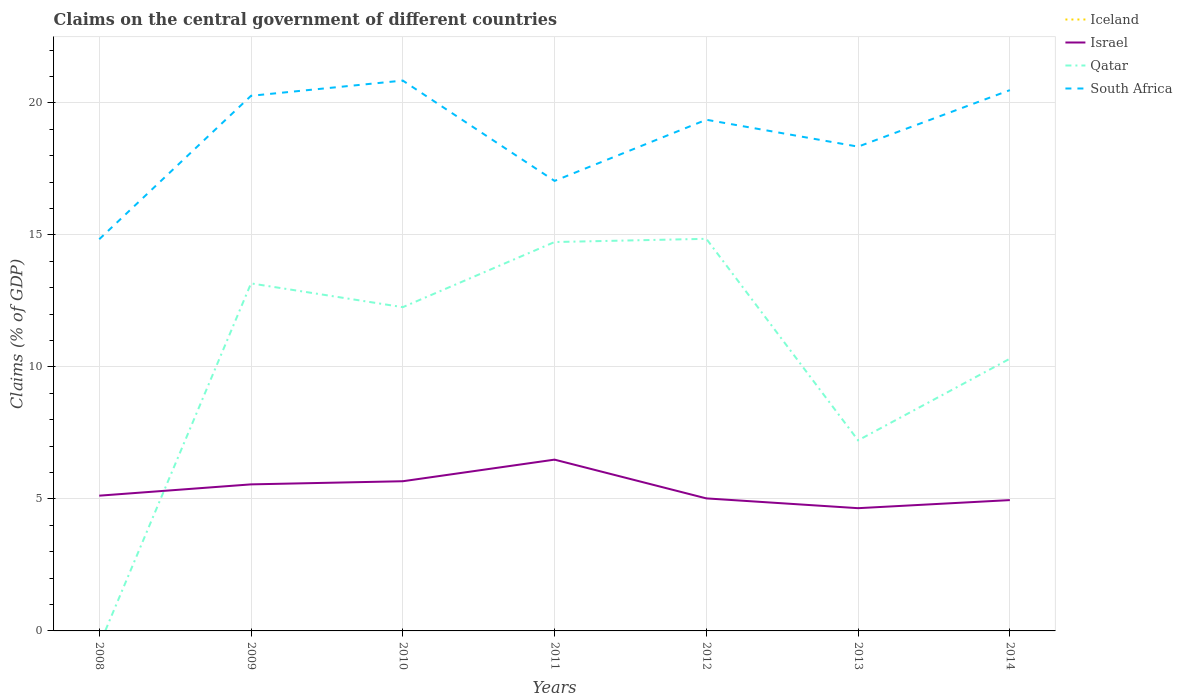Across all years, what is the maximum percentage of GDP claimed on the central government in Israel?
Offer a very short reply. 4.65. What is the total percentage of GDP claimed on the central government in South Africa in the graph?
Provide a short and direct response. 2.5. What is the difference between the highest and the second highest percentage of GDP claimed on the central government in Israel?
Ensure brevity in your answer.  1.84. What is the difference between the highest and the lowest percentage of GDP claimed on the central government in Iceland?
Your answer should be compact. 0. Is the percentage of GDP claimed on the central government in Qatar strictly greater than the percentage of GDP claimed on the central government in South Africa over the years?
Make the answer very short. Yes. How many years are there in the graph?
Your answer should be very brief. 7. Does the graph contain any zero values?
Ensure brevity in your answer.  Yes. Where does the legend appear in the graph?
Offer a very short reply. Top right. What is the title of the graph?
Provide a short and direct response. Claims on the central government of different countries. What is the label or title of the Y-axis?
Your answer should be compact. Claims (% of GDP). What is the Claims (% of GDP) of Iceland in 2008?
Offer a very short reply. 0. What is the Claims (% of GDP) of Israel in 2008?
Provide a succinct answer. 5.12. What is the Claims (% of GDP) in South Africa in 2008?
Make the answer very short. 14.84. What is the Claims (% of GDP) in Iceland in 2009?
Provide a short and direct response. 0. What is the Claims (% of GDP) of Israel in 2009?
Provide a succinct answer. 5.55. What is the Claims (% of GDP) in Qatar in 2009?
Make the answer very short. 13.16. What is the Claims (% of GDP) of South Africa in 2009?
Your answer should be very brief. 20.27. What is the Claims (% of GDP) of Israel in 2010?
Provide a succinct answer. 5.67. What is the Claims (% of GDP) of Qatar in 2010?
Provide a short and direct response. 12.26. What is the Claims (% of GDP) of South Africa in 2010?
Offer a terse response. 20.84. What is the Claims (% of GDP) of Israel in 2011?
Offer a terse response. 6.49. What is the Claims (% of GDP) in Qatar in 2011?
Give a very brief answer. 14.73. What is the Claims (% of GDP) of South Africa in 2011?
Keep it short and to the point. 17.04. What is the Claims (% of GDP) in Iceland in 2012?
Give a very brief answer. 0. What is the Claims (% of GDP) of Israel in 2012?
Your answer should be very brief. 5.02. What is the Claims (% of GDP) in Qatar in 2012?
Provide a short and direct response. 14.85. What is the Claims (% of GDP) in South Africa in 2012?
Offer a very short reply. 19.36. What is the Claims (% of GDP) in Israel in 2013?
Ensure brevity in your answer.  4.65. What is the Claims (% of GDP) in Qatar in 2013?
Keep it short and to the point. 7.22. What is the Claims (% of GDP) of South Africa in 2013?
Keep it short and to the point. 18.34. What is the Claims (% of GDP) of Israel in 2014?
Give a very brief answer. 4.96. What is the Claims (% of GDP) of Qatar in 2014?
Make the answer very short. 10.31. What is the Claims (% of GDP) in South Africa in 2014?
Offer a terse response. 20.48. Across all years, what is the maximum Claims (% of GDP) in Israel?
Offer a very short reply. 6.49. Across all years, what is the maximum Claims (% of GDP) in Qatar?
Offer a very short reply. 14.85. Across all years, what is the maximum Claims (% of GDP) in South Africa?
Give a very brief answer. 20.84. Across all years, what is the minimum Claims (% of GDP) of Israel?
Your answer should be very brief. 4.65. Across all years, what is the minimum Claims (% of GDP) of South Africa?
Provide a short and direct response. 14.84. What is the total Claims (% of GDP) of Israel in the graph?
Your response must be concise. 37.45. What is the total Claims (% of GDP) in Qatar in the graph?
Ensure brevity in your answer.  72.53. What is the total Claims (% of GDP) in South Africa in the graph?
Your answer should be very brief. 131.18. What is the difference between the Claims (% of GDP) of Israel in 2008 and that in 2009?
Keep it short and to the point. -0.43. What is the difference between the Claims (% of GDP) of South Africa in 2008 and that in 2009?
Provide a short and direct response. -5.43. What is the difference between the Claims (% of GDP) in Israel in 2008 and that in 2010?
Ensure brevity in your answer.  -0.55. What is the difference between the Claims (% of GDP) of South Africa in 2008 and that in 2010?
Keep it short and to the point. -6.01. What is the difference between the Claims (% of GDP) of Israel in 2008 and that in 2011?
Your answer should be very brief. -1.36. What is the difference between the Claims (% of GDP) in South Africa in 2008 and that in 2011?
Your answer should be compact. -2.21. What is the difference between the Claims (% of GDP) of Israel in 2008 and that in 2012?
Make the answer very short. 0.1. What is the difference between the Claims (% of GDP) in South Africa in 2008 and that in 2012?
Provide a short and direct response. -4.53. What is the difference between the Claims (% of GDP) of Israel in 2008 and that in 2013?
Ensure brevity in your answer.  0.47. What is the difference between the Claims (% of GDP) in South Africa in 2008 and that in 2013?
Offer a very short reply. -3.51. What is the difference between the Claims (% of GDP) in Israel in 2008 and that in 2014?
Your answer should be compact. 0.17. What is the difference between the Claims (% of GDP) of South Africa in 2008 and that in 2014?
Offer a terse response. -5.65. What is the difference between the Claims (% of GDP) in Israel in 2009 and that in 2010?
Keep it short and to the point. -0.12. What is the difference between the Claims (% of GDP) in Qatar in 2009 and that in 2010?
Your answer should be compact. 0.9. What is the difference between the Claims (% of GDP) in South Africa in 2009 and that in 2010?
Offer a terse response. -0.58. What is the difference between the Claims (% of GDP) of Israel in 2009 and that in 2011?
Give a very brief answer. -0.94. What is the difference between the Claims (% of GDP) in Qatar in 2009 and that in 2011?
Your answer should be very brief. -1.57. What is the difference between the Claims (% of GDP) of South Africa in 2009 and that in 2011?
Keep it short and to the point. 3.22. What is the difference between the Claims (% of GDP) of Israel in 2009 and that in 2012?
Make the answer very short. 0.53. What is the difference between the Claims (% of GDP) of Qatar in 2009 and that in 2012?
Your response must be concise. -1.69. What is the difference between the Claims (% of GDP) in South Africa in 2009 and that in 2012?
Offer a very short reply. 0.91. What is the difference between the Claims (% of GDP) in Israel in 2009 and that in 2013?
Your response must be concise. 0.9. What is the difference between the Claims (% of GDP) of Qatar in 2009 and that in 2013?
Keep it short and to the point. 5.94. What is the difference between the Claims (% of GDP) of South Africa in 2009 and that in 2013?
Make the answer very short. 1.93. What is the difference between the Claims (% of GDP) in Israel in 2009 and that in 2014?
Make the answer very short. 0.6. What is the difference between the Claims (% of GDP) in Qatar in 2009 and that in 2014?
Give a very brief answer. 2.85. What is the difference between the Claims (% of GDP) of South Africa in 2009 and that in 2014?
Your answer should be compact. -0.21. What is the difference between the Claims (% of GDP) in Israel in 2010 and that in 2011?
Offer a terse response. -0.82. What is the difference between the Claims (% of GDP) of Qatar in 2010 and that in 2011?
Make the answer very short. -2.47. What is the difference between the Claims (% of GDP) of Israel in 2010 and that in 2012?
Give a very brief answer. 0.65. What is the difference between the Claims (% of GDP) in Qatar in 2010 and that in 2012?
Ensure brevity in your answer.  -2.59. What is the difference between the Claims (% of GDP) in South Africa in 2010 and that in 2012?
Make the answer very short. 1.48. What is the difference between the Claims (% of GDP) in Israel in 2010 and that in 2013?
Give a very brief answer. 1.02. What is the difference between the Claims (% of GDP) of Qatar in 2010 and that in 2013?
Make the answer very short. 5.04. What is the difference between the Claims (% of GDP) of South Africa in 2010 and that in 2013?
Make the answer very short. 2.5. What is the difference between the Claims (% of GDP) of Israel in 2010 and that in 2014?
Make the answer very short. 0.71. What is the difference between the Claims (% of GDP) of Qatar in 2010 and that in 2014?
Make the answer very short. 1.95. What is the difference between the Claims (% of GDP) in South Africa in 2010 and that in 2014?
Provide a succinct answer. 0.36. What is the difference between the Claims (% of GDP) of Israel in 2011 and that in 2012?
Make the answer very short. 1.47. What is the difference between the Claims (% of GDP) of Qatar in 2011 and that in 2012?
Provide a short and direct response. -0.12. What is the difference between the Claims (% of GDP) of South Africa in 2011 and that in 2012?
Your answer should be very brief. -2.32. What is the difference between the Claims (% of GDP) in Israel in 2011 and that in 2013?
Make the answer very short. 1.84. What is the difference between the Claims (% of GDP) in Qatar in 2011 and that in 2013?
Provide a short and direct response. 7.51. What is the difference between the Claims (% of GDP) in South Africa in 2011 and that in 2013?
Provide a short and direct response. -1.3. What is the difference between the Claims (% of GDP) in Israel in 2011 and that in 2014?
Offer a terse response. 1.53. What is the difference between the Claims (% of GDP) in Qatar in 2011 and that in 2014?
Make the answer very short. 4.42. What is the difference between the Claims (% of GDP) of South Africa in 2011 and that in 2014?
Keep it short and to the point. -3.44. What is the difference between the Claims (% of GDP) in Israel in 2012 and that in 2013?
Ensure brevity in your answer.  0.37. What is the difference between the Claims (% of GDP) in Qatar in 2012 and that in 2013?
Your response must be concise. 7.63. What is the difference between the Claims (% of GDP) in South Africa in 2012 and that in 2013?
Keep it short and to the point. 1.02. What is the difference between the Claims (% of GDP) in Israel in 2012 and that in 2014?
Provide a short and direct response. 0.06. What is the difference between the Claims (% of GDP) in Qatar in 2012 and that in 2014?
Give a very brief answer. 4.54. What is the difference between the Claims (% of GDP) in South Africa in 2012 and that in 2014?
Make the answer very short. -1.12. What is the difference between the Claims (% of GDP) of Israel in 2013 and that in 2014?
Your answer should be compact. -0.31. What is the difference between the Claims (% of GDP) of Qatar in 2013 and that in 2014?
Offer a very short reply. -3.09. What is the difference between the Claims (% of GDP) of South Africa in 2013 and that in 2014?
Your answer should be very brief. -2.14. What is the difference between the Claims (% of GDP) in Israel in 2008 and the Claims (% of GDP) in Qatar in 2009?
Offer a terse response. -8.04. What is the difference between the Claims (% of GDP) in Israel in 2008 and the Claims (% of GDP) in South Africa in 2009?
Keep it short and to the point. -15.14. What is the difference between the Claims (% of GDP) in Israel in 2008 and the Claims (% of GDP) in Qatar in 2010?
Make the answer very short. -7.14. What is the difference between the Claims (% of GDP) of Israel in 2008 and the Claims (% of GDP) of South Africa in 2010?
Keep it short and to the point. -15.72. What is the difference between the Claims (% of GDP) of Israel in 2008 and the Claims (% of GDP) of Qatar in 2011?
Offer a very short reply. -9.61. What is the difference between the Claims (% of GDP) of Israel in 2008 and the Claims (% of GDP) of South Africa in 2011?
Offer a terse response. -11.92. What is the difference between the Claims (% of GDP) in Israel in 2008 and the Claims (% of GDP) in Qatar in 2012?
Provide a succinct answer. -9.73. What is the difference between the Claims (% of GDP) in Israel in 2008 and the Claims (% of GDP) in South Africa in 2012?
Make the answer very short. -14.24. What is the difference between the Claims (% of GDP) in Israel in 2008 and the Claims (% of GDP) in Qatar in 2013?
Provide a short and direct response. -2.1. What is the difference between the Claims (% of GDP) in Israel in 2008 and the Claims (% of GDP) in South Africa in 2013?
Offer a terse response. -13.22. What is the difference between the Claims (% of GDP) of Israel in 2008 and the Claims (% of GDP) of Qatar in 2014?
Your response must be concise. -5.19. What is the difference between the Claims (% of GDP) of Israel in 2008 and the Claims (% of GDP) of South Africa in 2014?
Ensure brevity in your answer.  -15.36. What is the difference between the Claims (% of GDP) of Israel in 2009 and the Claims (% of GDP) of Qatar in 2010?
Your answer should be compact. -6.71. What is the difference between the Claims (% of GDP) in Israel in 2009 and the Claims (% of GDP) in South Africa in 2010?
Give a very brief answer. -15.29. What is the difference between the Claims (% of GDP) in Qatar in 2009 and the Claims (% of GDP) in South Africa in 2010?
Give a very brief answer. -7.68. What is the difference between the Claims (% of GDP) of Israel in 2009 and the Claims (% of GDP) of Qatar in 2011?
Give a very brief answer. -9.18. What is the difference between the Claims (% of GDP) of Israel in 2009 and the Claims (% of GDP) of South Africa in 2011?
Your response must be concise. -11.49. What is the difference between the Claims (% of GDP) in Qatar in 2009 and the Claims (% of GDP) in South Africa in 2011?
Provide a succinct answer. -3.88. What is the difference between the Claims (% of GDP) in Israel in 2009 and the Claims (% of GDP) in South Africa in 2012?
Make the answer very short. -13.81. What is the difference between the Claims (% of GDP) in Qatar in 2009 and the Claims (% of GDP) in South Africa in 2012?
Your answer should be compact. -6.2. What is the difference between the Claims (% of GDP) in Israel in 2009 and the Claims (% of GDP) in Qatar in 2013?
Make the answer very short. -1.67. What is the difference between the Claims (% of GDP) in Israel in 2009 and the Claims (% of GDP) in South Africa in 2013?
Your answer should be very brief. -12.79. What is the difference between the Claims (% of GDP) of Qatar in 2009 and the Claims (% of GDP) of South Africa in 2013?
Your answer should be very brief. -5.18. What is the difference between the Claims (% of GDP) of Israel in 2009 and the Claims (% of GDP) of Qatar in 2014?
Offer a terse response. -4.76. What is the difference between the Claims (% of GDP) of Israel in 2009 and the Claims (% of GDP) of South Africa in 2014?
Provide a succinct answer. -14.93. What is the difference between the Claims (% of GDP) in Qatar in 2009 and the Claims (% of GDP) in South Africa in 2014?
Provide a short and direct response. -7.32. What is the difference between the Claims (% of GDP) of Israel in 2010 and the Claims (% of GDP) of Qatar in 2011?
Your response must be concise. -9.06. What is the difference between the Claims (% of GDP) in Israel in 2010 and the Claims (% of GDP) in South Africa in 2011?
Provide a short and direct response. -11.38. What is the difference between the Claims (% of GDP) in Qatar in 2010 and the Claims (% of GDP) in South Africa in 2011?
Provide a succinct answer. -4.78. What is the difference between the Claims (% of GDP) of Israel in 2010 and the Claims (% of GDP) of Qatar in 2012?
Ensure brevity in your answer.  -9.18. What is the difference between the Claims (% of GDP) in Israel in 2010 and the Claims (% of GDP) in South Africa in 2012?
Offer a terse response. -13.69. What is the difference between the Claims (% of GDP) of Qatar in 2010 and the Claims (% of GDP) of South Africa in 2012?
Offer a terse response. -7.1. What is the difference between the Claims (% of GDP) of Israel in 2010 and the Claims (% of GDP) of Qatar in 2013?
Provide a short and direct response. -1.55. What is the difference between the Claims (% of GDP) of Israel in 2010 and the Claims (% of GDP) of South Africa in 2013?
Keep it short and to the point. -12.67. What is the difference between the Claims (% of GDP) of Qatar in 2010 and the Claims (% of GDP) of South Africa in 2013?
Give a very brief answer. -6.08. What is the difference between the Claims (% of GDP) in Israel in 2010 and the Claims (% of GDP) in Qatar in 2014?
Keep it short and to the point. -4.64. What is the difference between the Claims (% of GDP) of Israel in 2010 and the Claims (% of GDP) of South Africa in 2014?
Keep it short and to the point. -14.81. What is the difference between the Claims (% of GDP) of Qatar in 2010 and the Claims (% of GDP) of South Africa in 2014?
Give a very brief answer. -8.22. What is the difference between the Claims (% of GDP) of Israel in 2011 and the Claims (% of GDP) of Qatar in 2012?
Offer a very short reply. -8.36. What is the difference between the Claims (% of GDP) of Israel in 2011 and the Claims (% of GDP) of South Africa in 2012?
Your response must be concise. -12.87. What is the difference between the Claims (% of GDP) of Qatar in 2011 and the Claims (% of GDP) of South Africa in 2012?
Keep it short and to the point. -4.63. What is the difference between the Claims (% of GDP) of Israel in 2011 and the Claims (% of GDP) of Qatar in 2013?
Keep it short and to the point. -0.73. What is the difference between the Claims (% of GDP) in Israel in 2011 and the Claims (% of GDP) in South Africa in 2013?
Your answer should be very brief. -11.85. What is the difference between the Claims (% of GDP) in Qatar in 2011 and the Claims (% of GDP) in South Africa in 2013?
Offer a terse response. -3.61. What is the difference between the Claims (% of GDP) in Israel in 2011 and the Claims (% of GDP) in Qatar in 2014?
Your answer should be very brief. -3.82. What is the difference between the Claims (% of GDP) of Israel in 2011 and the Claims (% of GDP) of South Africa in 2014?
Offer a terse response. -13.99. What is the difference between the Claims (% of GDP) in Qatar in 2011 and the Claims (% of GDP) in South Africa in 2014?
Give a very brief answer. -5.75. What is the difference between the Claims (% of GDP) in Israel in 2012 and the Claims (% of GDP) in Qatar in 2013?
Keep it short and to the point. -2.2. What is the difference between the Claims (% of GDP) in Israel in 2012 and the Claims (% of GDP) in South Africa in 2013?
Your response must be concise. -13.32. What is the difference between the Claims (% of GDP) in Qatar in 2012 and the Claims (% of GDP) in South Africa in 2013?
Offer a terse response. -3.49. What is the difference between the Claims (% of GDP) in Israel in 2012 and the Claims (% of GDP) in Qatar in 2014?
Your answer should be compact. -5.29. What is the difference between the Claims (% of GDP) of Israel in 2012 and the Claims (% of GDP) of South Africa in 2014?
Provide a succinct answer. -15.46. What is the difference between the Claims (% of GDP) in Qatar in 2012 and the Claims (% of GDP) in South Africa in 2014?
Provide a short and direct response. -5.63. What is the difference between the Claims (% of GDP) of Israel in 2013 and the Claims (% of GDP) of Qatar in 2014?
Make the answer very short. -5.66. What is the difference between the Claims (% of GDP) in Israel in 2013 and the Claims (% of GDP) in South Africa in 2014?
Offer a terse response. -15.83. What is the difference between the Claims (% of GDP) of Qatar in 2013 and the Claims (% of GDP) of South Africa in 2014?
Offer a very short reply. -13.26. What is the average Claims (% of GDP) of Iceland per year?
Give a very brief answer. 0. What is the average Claims (% of GDP) of Israel per year?
Ensure brevity in your answer.  5.35. What is the average Claims (% of GDP) in Qatar per year?
Make the answer very short. 10.36. What is the average Claims (% of GDP) in South Africa per year?
Ensure brevity in your answer.  18.74. In the year 2008, what is the difference between the Claims (% of GDP) in Israel and Claims (% of GDP) in South Africa?
Give a very brief answer. -9.71. In the year 2009, what is the difference between the Claims (% of GDP) in Israel and Claims (% of GDP) in Qatar?
Give a very brief answer. -7.61. In the year 2009, what is the difference between the Claims (% of GDP) of Israel and Claims (% of GDP) of South Africa?
Give a very brief answer. -14.72. In the year 2009, what is the difference between the Claims (% of GDP) of Qatar and Claims (% of GDP) of South Africa?
Provide a short and direct response. -7.11. In the year 2010, what is the difference between the Claims (% of GDP) of Israel and Claims (% of GDP) of Qatar?
Provide a short and direct response. -6.59. In the year 2010, what is the difference between the Claims (% of GDP) in Israel and Claims (% of GDP) in South Africa?
Provide a short and direct response. -15.18. In the year 2010, what is the difference between the Claims (% of GDP) in Qatar and Claims (% of GDP) in South Africa?
Your response must be concise. -8.58. In the year 2011, what is the difference between the Claims (% of GDP) of Israel and Claims (% of GDP) of Qatar?
Offer a very short reply. -8.24. In the year 2011, what is the difference between the Claims (% of GDP) of Israel and Claims (% of GDP) of South Africa?
Your answer should be compact. -10.56. In the year 2011, what is the difference between the Claims (% of GDP) in Qatar and Claims (% of GDP) in South Africa?
Your answer should be very brief. -2.32. In the year 2012, what is the difference between the Claims (% of GDP) of Israel and Claims (% of GDP) of Qatar?
Your answer should be very brief. -9.83. In the year 2012, what is the difference between the Claims (% of GDP) of Israel and Claims (% of GDP) of South Africa?
Provide a short and direct response. -14.34. In the year 2012, what is the difference between the Claims (% of GDP) in Qatar and Claims (% of GDP) in South Africa?
Your response must be concise. -4.51. In the year 2013, what is the difference between the Claims (% of GDP) of Israel and Claims (% of GDP) of Qatar?
Ensure brevity in your answer.  -2.57. In the year 2013, what is the difference between the Claims (% of GDP) of Israel and Claims (% of GDP) of South Africa?
Keep it short and to the point. -13.69. In the year 2013, what is the difference between the Claims (% of GDP) in Qatar and Claims (% of GDP) in South Africa?
Provide a succinct answer. -11.12. In the year 2014, what is the difference between the Claims (% of GDP) in Israel and Claims (% of GDP) in Qatar?
Your response must be concise. -5.36. In the year 2014, what is the difference between the Claims (% of GDP) of Israel and Claims (% of GDP) of South Africa?
Give a very brief answer. -15.53. In the year 2014, what is the difference between the Claims (% of GDP) in Qatar and Claims (% of GDP) in South Africa?
Give a very brief answer. -10.17. What is the ratio of the Claims (% of GDP) in Israel in 2008 to that in 2009?
Offer a very short reply. 0.92. What is the ratio of the Claims (% of GDP) of South Africa in 2008 to that in 2009?
Keep it short and to the point. 0.73. What is the ratio of the Claims (% of GDP) in Israel in 2008 to that in 2010?
Ensure brevity in your answer.  0.9. What is the ratio of the Claims (% of GDP) in South Africa in 2008 to that in 2010?
Ensure brevity in your answer.  0.71. What is the ratio of the Claims (% of GDP) in Israel in 2008 to that in 2011?
Your answer should be very brief. 0.79. What is the ratio of the Claims (% of GDP) in South Africa in 2008 to that in 2011?
Your answer should be very brief. 0.87. What is the ratio of the Claims (% of GDP) of Israel in 2008 to that in 2012?
Give a very brief answer. 1.02. What is the ratio of the Claims (% of GDP) in South Africa in 2008 to that in 2012?
Make the answer very short. 0.77. What is the ratio of the Claims (% of GDP) of Israel in 2008 to that in 2013?
Offer a terse response. 1.1. What is the ratio of the Claims (% of GDP) in South Africa in 2008 to that in 2013?
Make the answer very short. 0.81. What is the ratio of the Claims (% of GDP) in Israel in 2008 to that in 2014?
Keep it short and to the point. 1.03. What is the ratio of the Claims (% of GDP) of South Africa in 2008 to that in 2014?
Your answer should be very brief. 0.72. What is the ratio of the Claims (% of GDP) in Israel in 2009 to that in 2010?
Your answer should be very brief. 0.98. What is the ratio of the Claims (% of GDP) of Qatar in 2009 to that in 2010?
Your response must be concise. 1.07. What is the ratio of the Claims (% of GDP) in South Africa in 2009 to that in 2010?
Give a very brief answer. 0.97. What is the ratio of the Claims (% of GDP) of Israel in 2009 to that in 2011?
Your response must be concise. 0.86. What is the ratio of the Claims (% of GDP) in Qatar in 2009 to that in 2011?
Make the answer very short. 0.89. What is the ratio of the Claims (% of GDP) in South Africa in 2009 to that in 2011?
Offer a terse response. 1.19. What is the ratio of the Claims (% of GDP) of Israel in 2009 to that in 2012?
Ensure brevity in your answer.  1.11. What is the ratio of the Claims (% of GDP) of Qatar in 2009 to that in 2012?
Your answer should be very brief. 0.89. What is the ratio of the Claims (% of GDP) in South Africa in 2009 to that in 2012?
Keep it short and to the point. 1.05. What is the ratio of the Claims (% of GDP) in Israel in 2009 to that in 2013?
Your response must be concise. 1.19. What is the ratio of the Claims (% of GDP) of Qatar in 2009 to that in 2013?
Your answer should be very brief. 1.82. What is the ratio of the Claims (% of GDP) of South Africa in 2009 to that in 2013?
Make the answer very short. 1.1. What is the ratio of the Claims (% of GDP) of Israel in 2009 to that in 2014?
Give a very brief answer. 1.12. What is the ratio of the Claims (% of GDP) of Qatar in 2009 to that in 2014?
Make the answer very short. 1.28. What is the ratio of the Claims (% of GDP) of Israel in 2010 to that in 2011?
Provide a short and direct response. 0.87. What is the ratio of the Claims (% of GDP) in Qatar in 2010 to that in 2011?
Give a very brief answer. 0.83. What is the ratio of the Claims (% of GDP) of South Africa in 2010 to that in 2011?
Offer a terse response. 1.22. What is the ratio of the Claims (% of GDP) in Israel in 2010 to that in 2012?
Your answer should be compact. 1.13. What is the ratio of the Claims (% of GDP) in Qatar in 2010 to that in 2012?
Offer a terse response. 0.83. What is the ratio of the Claims (% of GDP) in South Africa in 2010 to that in 2012?
Offer a terse response. 1.08. What is the ratio of the Claims (% of GDP) in Israel in 2010 to that in 2013?
Keep it short and to the point. 1.22. What is the ratio of the Claims (% of GDP) of Qatar in 2010 to that in 2013?
Your response must be concise. 1.7. What is the ratio of the Claims (% of GDP) in South Africa in 2010 to that in 2013?
Provide a succinct answer. 1.14. What is the ratio of the Claims (% of GDP) in Israel in 2010 to that in 2014?
Ensure brevity in your answer.  1.14. What is the ratio of the Claims (% of GDP) of Qatar in 2010 to that in 2014?
Provide a short and direct response. 1.19. What is the ratio of the Claims (% of GDP) in South Africa in 2010 to that in 2014?
Offer a very short reply. 1.02. What is the ratio of the Claims (% of GDP) of Israel in 2011 to that in 2012?
Ensure brevity in your answer.  1.29. What is the ratio of the Claims (% of GDP) in South Africa in 2011 to that in 2012?
Give a very brief answer. 0.88. What is the ratio of the Claims (% of GDP) in Israel in 2011 to that in 2013?
Provide a succinct answer. 1.4. What is the ratio of the Claims (% of GDP) of Qatar in 2011 to that in 2013?
Keep it short and to the point. 2.04. What is the ratio of the Claims (% of GDP) of South Africa in 2011 to that in 2013?
Your answer should be compact. 0.93. What is the ratio of the Claims (% of GDP) of Israel in 2011 to that in 2014?
Offer a very short reply. 1.31. What is the ratio of the Claims (% of GDP) in Qatar in 2011 to that in 2014?
Provide a short and direct response. 1.43. What is the ratio of the Claims (% of GDP) in South Africa in 2011 to that in 2014?
Your response must be concise. 0.83. What is the ratio of the Claims (% of GDP) of Israel in 2012 to that in 2013?
Provide a short and direct response. 1.08. What is the ratio of the Claims (% of GDP) of Qatar in 2012 to that in 2013?
Your response must be concise. 2.06. What is the ratio of the Claims (% of GDP) in South Africa in 2012 to that in 2013?
Ensure brevity in your answer.  1.06. What is the ratio of the Claims (% of GDP) in Qatar in 2012 to that in 2014?
Your answer should be compact. 1.44. What is the ratio of the Claims (% of GDP) in South Africa in 2012 to that in 2014?
Offer a terse response. 0.95. What is the ratio of the Claims (% of GDP) in Israel in 2013 to that in 2014?
Offer a very short reply. 0.94. What is the ratio of the Claims (% of GDP) of Qatar in 2013 to that in 2014?
Offer a very short reply. 0.7. What is the ratio of the Claims (% of GDP) of South Africa in 2013 to that in 2014?
Provide a short and direct response. 0.9. What is the difference between the highest and the second highest Claims (% of GDP) of Israel?
Give a very brief answer. 0.82. What is the difference between the highest and the second highest Claims (% of GDP) in Qatar?
Keep it short and to the point. 0.12. What is the difference between the highest and the second highest Claims (% of GDP) of South Africa?
Make the answer very short. 0.36. What is the difference between the highest and the lowest Claims (% of GDP) of Israel?
Make the answer very short. 1.84. What is the difference between the highest and the lowest Claims (% of GDP) of Qatar?
Offer a very short reply. 14.85. What is the difference between the highest and the lowest Claims (% of GDP) in South Africa?
Offer a terse response. 6.01. 